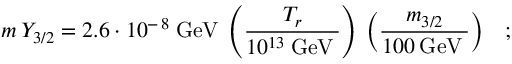Convert formula to latex. <formula><loc_0><loc_0><loc_500><loc_500>m \, Y _ { 3 / 2 } = 2 . 6 \cdot 1 0 ^ { - \, 8 } \, G e V \, \left ( \frac { T _ { r } } { 1 0 ^ { 1 3 } \, G e V \, } \right ) \, \left ( \frac { m _ { 3 / 2 } } { 1 0 0 \, G e V \, } \right ) \, ;</formula> 